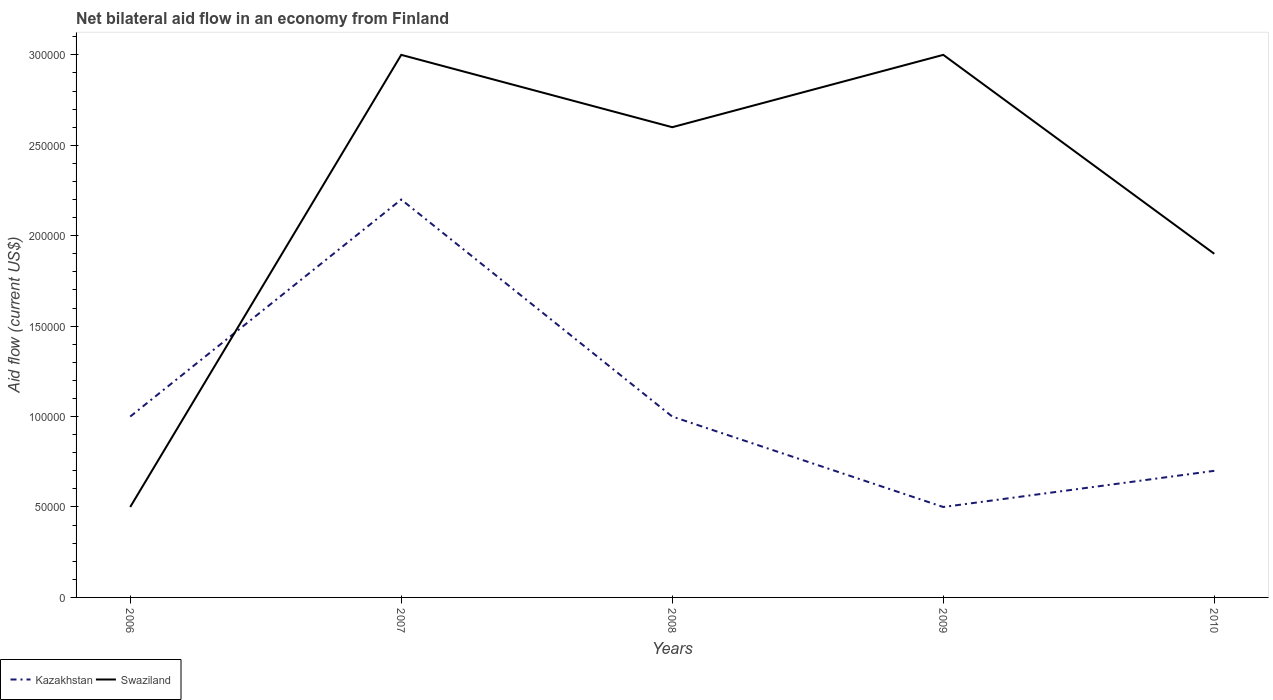Does the line corresponding to Swaziland intersect with the line corresponding to Kazakhstan?
Provide a succinct answer. Yes. Is the number of lines equal to the number of legend labels?
Offer a terse response. Yes. Across all years, what is the maximum net bilateral aid flow in Swaziland?
Offer a terse response. 5.00e+04. What is the difference between the highest and the lowest net bilateral aid flow in Swaziland?
Your answer should be very brief. 3. Is the net bilateral aid flow in Swaziland strictly greater than the net bilateral aid flow in Kazakhstan over the years?
Offer a terse response. No. How many lines are there?
Keep it short and to the point. 2. What is the difference between two consecutive major ticks on the Y-axis?
Ensure brevity in your answer.  5.00e+04. Does the graph contain grids?
Keep it short and to the point. No. How many legend labels are there?
Offer a very short reply. 2. What is the title of the graph?
Provide a succinct answer. Net bilateral aid flow in an economy from Finland. What is the label or title of the X-axis?
Give a very brief answer. Years. What is the label or title of the Y-axis?
Offer a terse response. Aid flow (current US$). What is the Aid flow (current US$) in Kazakhstan in 2006?
Provide a short and direct response. 1.00e+05. What is the Aid flow (current US$) of Kazakhstan in 2007?
Provide a succinct answer. 2.20e+05. What is the Aid flow (current US$) in Swaziland in 2007?
Your response must be concise. 3.00e+05. What is the Aid flow (current US$) in Kazakhstan in 2008?
Provide a succinct answer. 1.00e+05. What is the Aid flow (current US$) of Swaziland in 2009?
Your response must be concise. 3.00e+05. Across all years, what is the maximum Aid flow (current US$) in Swaziland?
Ensure brevity in your answer.  3.00e+05. What is the total Aid flow (current US$) in Kazakhstan in the graph?
Ensure brevity in your answer.  5.40e+05. What is the total Aid flow (current US$) of Swaziland in the graph?
Provide a succinct answer. 1.10e+06. What is the difference between the Aid flow (current US$) in Kazakhstan in 2006 and that in 2007?
Give a very brief answer. -1.20e+05. What is the difference between the Aid flow (current US$) of Kazakhstan in 2006 and that in 2008?
Offer a very short reply. 0. What is the difference between the Aid flow (current US$) in Kazakhstan in 2006 and that in 2009?
Make the answer very short. 5.00e+04. What is the difference between the Aid flow (current US$) of Swaziland in 2006 and that in 2010?
Make the answer very short. -1.40e+05. What is the difference between the Aid flow (current US$) of Swaziland in 2007 and that in 2009?
Keep it short and to the point. 0. What is the difference between the Aid flow (current US$) of Kazakhstan in 2008 and that in 2009?
Keep it short and to the point. 5.00e+04. What is the difference between the Aid flow (current US$) in Kazakhstan in 2008 and that in 2010?
Offer a terse response. 3.00e+04. What is the difference between the Aid flow (current US$) of Swaziland in 2009 and that in 2010?
Provide a short and direct response. 1.10e+05. What is the difference between the Aid flow (current US$) in Kazakhstan in 2006 and the Aid flow (current US$) in Swaziland in 2009?
Provide a short and direct response. -2.00e+05. What is the difference between the Aid flow (current US$) of Kazakhstan in 2006 and the Aid flow (current US$) of Swaziland in 2010?
Offer a very short reply. -9.00e+04. What is the difference between the Aid flow (current US$) in Kazakhstan in 2007 and the Aid flow (current US$) in Swaziland in 2008?
Keep it short and to the point. -4.00e+04. What is the difference between the Aid flow (current US$) of Kazakhstan in 2007 and the Aid flow (current US$) of Swaziland in 2009?
Offer a very short reply. -8.00e+04. What is the difference between the Aid flow (current US$) in Kazakhstan in 2007 and the Aid flow (current US$) in Swaziland in 2010?
Give a very brief answer. 3.00e+04. What is the difference between the Aid flow (current US$) of Kazakhstan in 2008 and the Aid flow (current US$) of Swaziland in 2010?
Your response must be concise. -9.00e+04. What is the difference between the Aid flow (current US$) in Kazakhstan in 2009 and the Aid flow (current US$) in Swaziland in 2010?
Ensure brevity in your answer.  -1.40e+05. What is the average Aid flow (current US$) in Kazakhstan per year?
Your answer should be compact. 1.08e+05. What is the ratio of the Aid flow (current US$) of Kazakhstan in 2006 to that in 2007?
Your answer should be very brief. 0.45. What is the ratio of the Aid flow (current US$) of Kazakhstan in 2006 to that in 2008?
Make the answer very short. 1. What is the ratio of the Aid flow (current US$) of Swaziland in 2006 to that in 2008?
Your answer should be very brief. 0.19. What is the ratio of the Aid flow (current US$) of Kazakhstan in 2006 to that in 2010?
Your answer should be very brief. 1.43. What is the ratio of the Aid flow (current US$) in Swaziland in 2006 to that in 2010?
Provide a succinct answer. 0.26. What is the ratio of the Aid flow (current US$) of Swaziland in 2007 to that in 2008?
Make the answer very short. 1.15. What is the ratio of the Aid flow (current US$) in Kazakhstan in 2007 to that in 2009?
Provide a short and direct response. 4.4. What is the ratio of the Aid flow (current US$) in Swaziland in 2007 to that in 2009?
Your answer should be very brief. 1. What is the ratio of the Aid flow (current US$) in Kazakhstan in 2007 to that in 2010?
Ensure brevity in your answer.  3.14. What is the ratio of the Aid flow (current US$) in Swaziland in 2007 to that in 2010?
Give a very brief answer. 1.58. What is the ratio of the Aid flow (current US$) of Swaziland in 2008 to that in 2009?
Keep it short and to the point. 0.87. What is the ratio of the Aid flow (current US$) in Kazakhstan in 2008 to that in 2010?
Give a very brief answer. 1.43. What is the ratio of the Aid flow (current US$) of Swaziland in 2008 to that in 2010?
Provide a short and direct response. 1.37. What is the ratio of the Aid flow (current US$) of Swaziland in 2009 to that in 2010?
Your answer should be very brief. 1.58. What is the difference between the highest and the lowest Aid flow (current US$) in Swaziland?
Ensure brevity in your answer.  2.50e+05. 